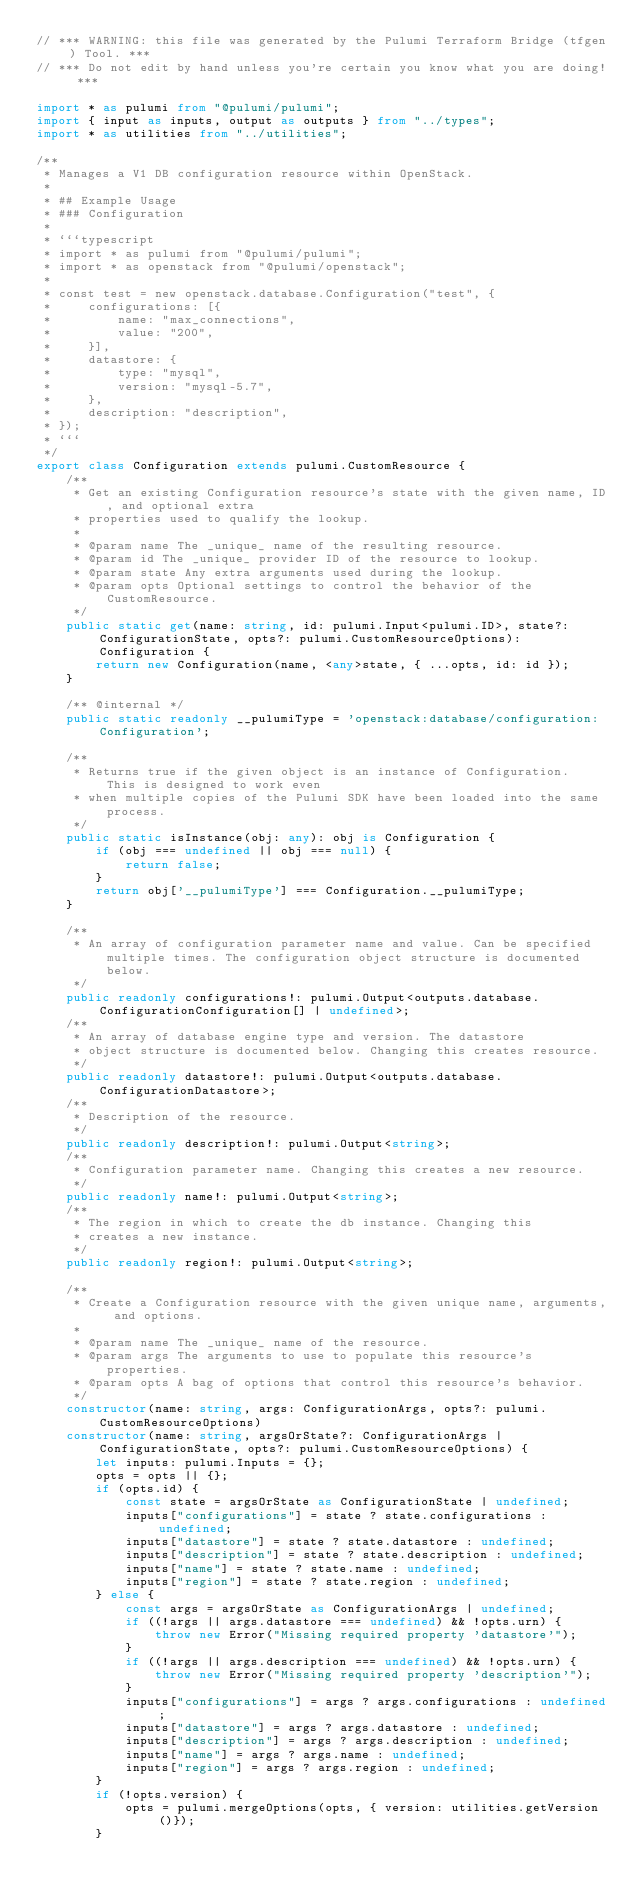<code> <loc_0><loc_0><loc_500><loc_500><_TypeScript_>// *** WARNING: this file was generated by the Pulumi Terraform Bridge (tfgen) Tool. ***
// *** Do not edit by hand unless you're certain you know what you are doing! ***

import * as pulumi from "@pulumi/pulumi";
import { input as inputs, output as outputs } from "../types";
import * as utilities from "../utilities";

/**
 * Manages a V1 DB configuration resource within OpenStack.
 *
 * ## Example Usage
 * ### Configuration
 *
 * ```typescript
 * import * as pulumi from "@pulumi/pulumi";
 * import * as openstack from "@pulumi/openstack";
 *
 * const test = new openstack.database.Configuration("test", {
 *     configurations: [{
 *         name: "max_connections",
 *         value: "200",
 *     }],
 *     datastore: {
 *         type: "mysql",
 *         version: "mysql-5.7",
 *     },
 *     description: "description",
 * });
 * ```
 */
export class Configuration extends pulumi.CustomResource {
    /**
     * Get an existing Configuration resource's state with the given name, ID, and optional extra
     * properties used to qualify the lookup.
     *
     * @param name The _unique_ name of the resulting resource.
     * @param id The _unique_ provider ID of the resource to lookup.
     * @param state Any extra arguments used during the lookup.
     * @param opts Optional settings to control the behavior of the CustomResource.
     */
    public static get(name: string, id: pulumi.Input<pulumi.ID>, state?: ConfigurationState, opts?: pulumi.CustomResourceOptions): Configuration {
        return new Configuration(name, <any>state, { ...opts, id: id });
    }

    /** @internal */
    public static readonly __pulumiType = 'openstack:database/configuration:Configuration';

    /**
     * Returns true if the given object is an instance of Configuration.  This is designed to work even
     * when multiple copies of the Pulumi SDK have been loaded into the same process.
     */
    public static isInstance(obj: any): obj is Configuration {
        if (obj === undefined || obj === null) {
            return false;
        }
        return obj['__pulumiType'] === Configuration.__pulumiType;
    }

    /**
     * An array of configuration parameter name and value. Can be specified multiple times. The configuration object structure is documented below.
     */
    public readonly configurations!: pulumi.Output<outputs.database.ConfigurationConfiguration[] | undefined>;
    /**
     * An array of database engine type and version. The datastore
     * object structure is documented below. Changing this creates resource.
     */
    public readonly datastore!: pulumi.Output<outputs.database.ConfigurationDatastore>;
    /**
     * Description of the resource.
     */
    public readonly description!: pulumi.Output<string>;
    /**
     * Configuration parameter name. Changing this creates a new resource.
     */
    public readonly name!: pulumi.Output<string>;
    /**
     * The region in which to create the db instance. Changing this
     * creates a new instance.
     */
    public readonly region!: pulumi.Output<string>;

    /**
     * Create a Configuration resource with the given unique name, arguments, and options.
     *
     * @param name The _unique_ name of the resource.
     * @param args The arguments to use to populate this resource's properties.
     * @param opts A bag of options that control this resource's behavior.
     */
    constructor(name: string, args: ConfigurationArgs, opts?: pulumi.CustomResourceOptions)
    constructor(name: string, argsOrState?: ConfigurationArgs | ConfigurationState, opts?: pulumi.CustomResourceOptions) {
        let inputs: pulumi.Inputs = {};
        opts = opts || {};
        if (opts.id) {
            const state = argsOrState as ConfigurationState | undefined;
            inputs["configurations"] = state ? state.configurations : undefined;
            inputs["datastore"] = state ? state.datastore : undefined;
            inputs["description"] = state ? state.description : undefined;
            inputs["name"] = state ? state.name : undefined;
            inputs["region"] = state ? state.region : undefined;
        } else {
            const args = argsOrState as ConfigurationArgs | undefined;
            if ((!args || args.datastore === undefined) && !opts.urn) {
                throw new Error("Missing required property 'datastore'");
            }
            if ((!args || args.description === undefined) && !opts.urn) {
                throw new Error("Missing required property 'description'");
            }
            inputs["configurations"] = args ? args.configurations : undefined;
            inputs["datastore"] = args ? args.datastore : undefined;
            inputs["description"] = args ? args.description : undefined;
            inputs["name"] = args ? args.name : undefined;
            inputs["region"] = args ? args.region : undefined;
        }
        if (!opts.version) {
            opts = pulumi.mergeOptions(opts, { version: utilities.getVersion()});
        }</code> 